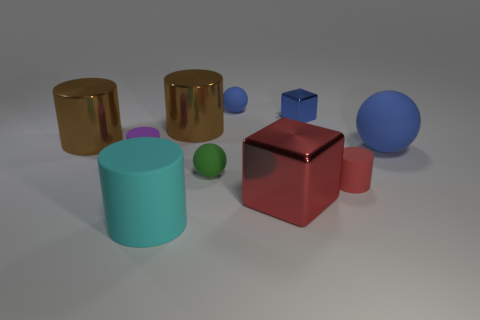Subtract all red cylinders. How many cylinders are left? 4 Subtract all tiny red cylinders. How many cylinders are left? 4 Subtract all blue cylinders. Subtract all yellow spheres. How many cylinders are left? 5 Subtract all blocks. How many objects are left? 8 Subtract 0 purple blocks. How many objects are left? 10 Subtract all small purple objects. Subtract all brown metallic objects. How many objects are left? 7 Add 3 blue spheres. How many blue spheres are left? 5 Add 2 big shiny cubes. How many big shiny cubes exist? 3 